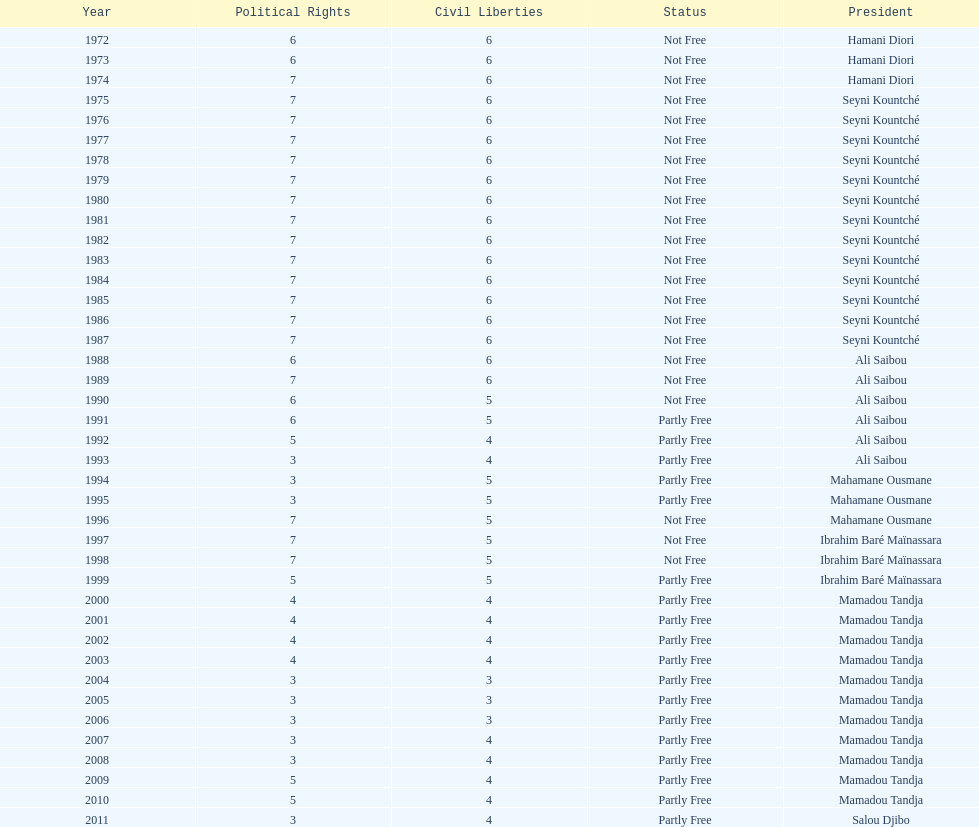In what time frame did civil liberties decline to less than 6? 18 years. 